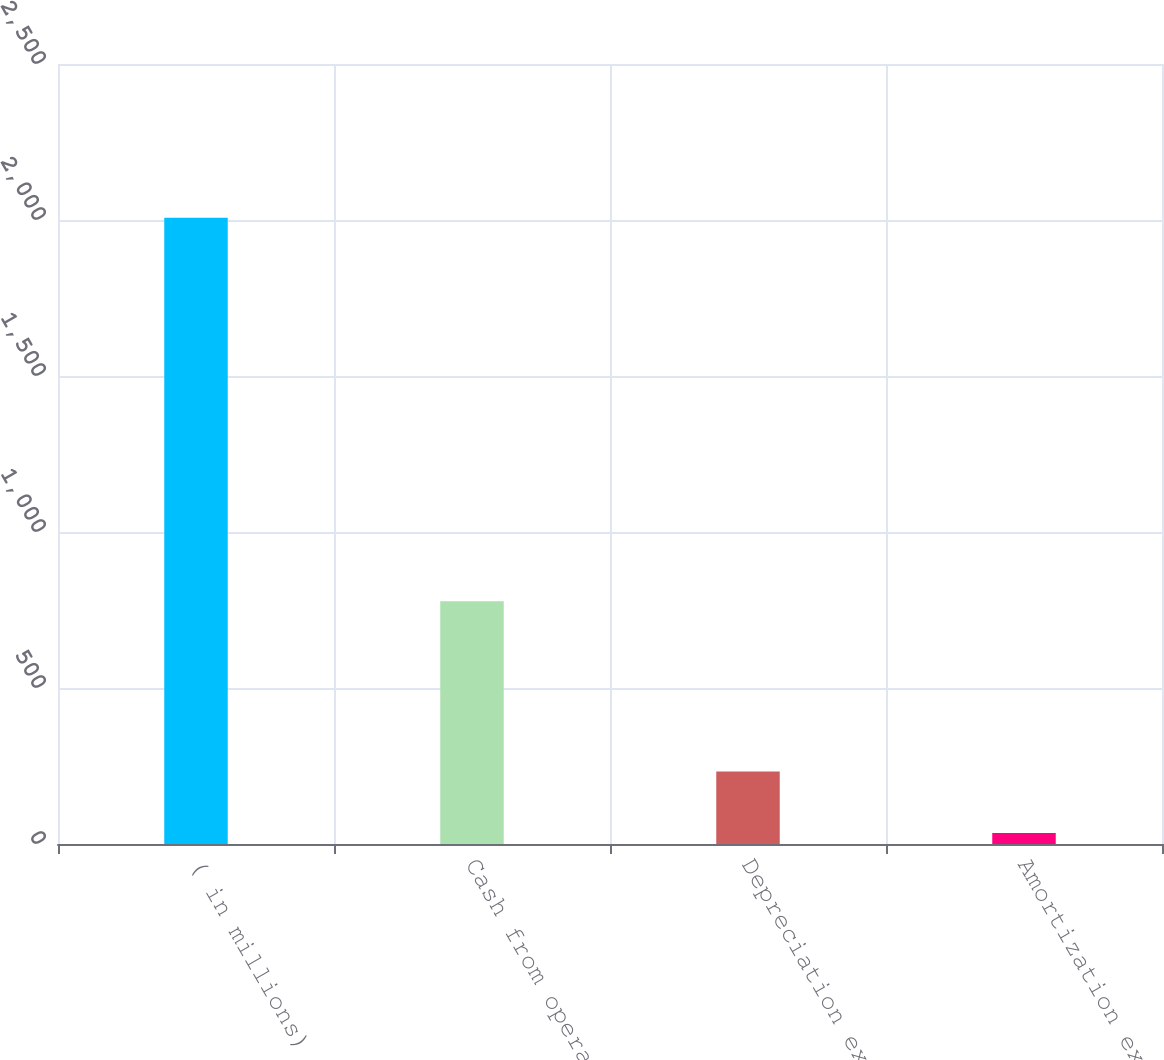Convert chart to OTSL. <chart><loc_0><loc_0><loc_500><loc_500><bar_chart><fcel>( in millions)<fcel>Cash from operations<fcel>Depreciation expense<fcel>Amortization expense<nl><fcel>2007<fcel>778<fcel>232.2<fcel>35<nl></chart> 